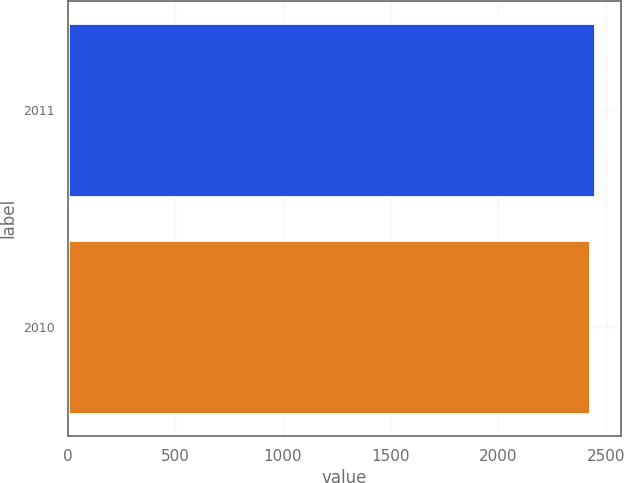Convert chart. <chart><loc_0><loc_0><loc_500><loc_500><bar_chart><fcel>2011<fcel>2010<nl><fcel>2448<fcel>2426<nl></chart> 